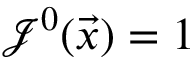<formula> <loc_0><loc_0><loc_500><loc_500>\mathcal { J } ^ { 0 } ( \vec { x } ) = 1</formula> 